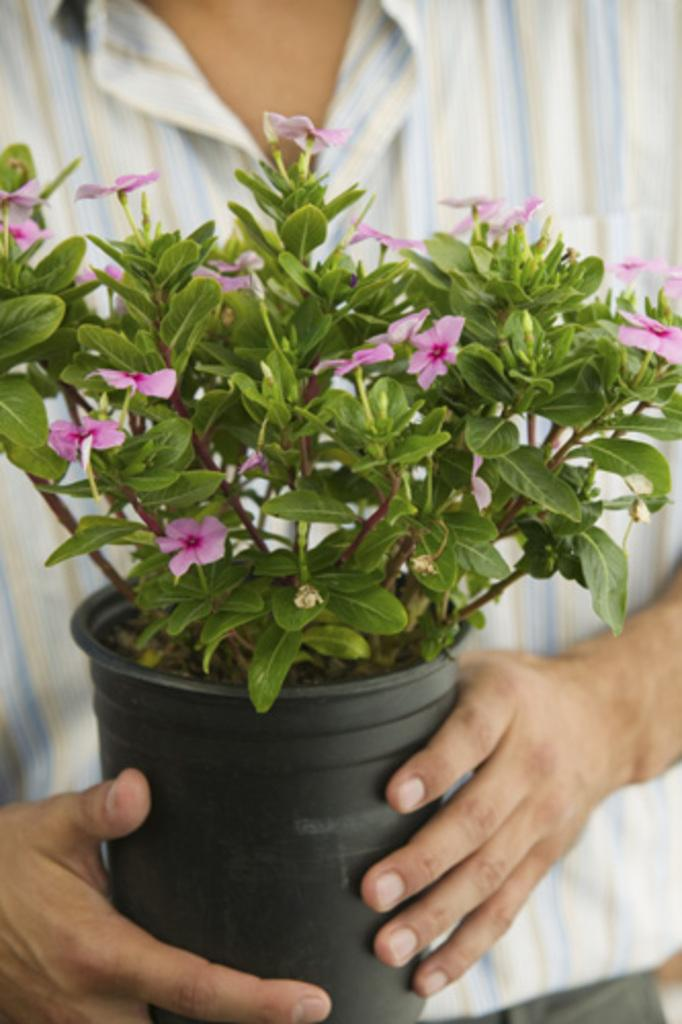What is present in the image? There is a person in the image. Can you describe the person's clothing? The person is wearing a striped shirt. What is the person holding in the image? The person is holding a flower plant pot. What type of goat can be seen in the image? There is no goat present in the image. What is the person doing with the jar in the image? There is no jar present in the image. 